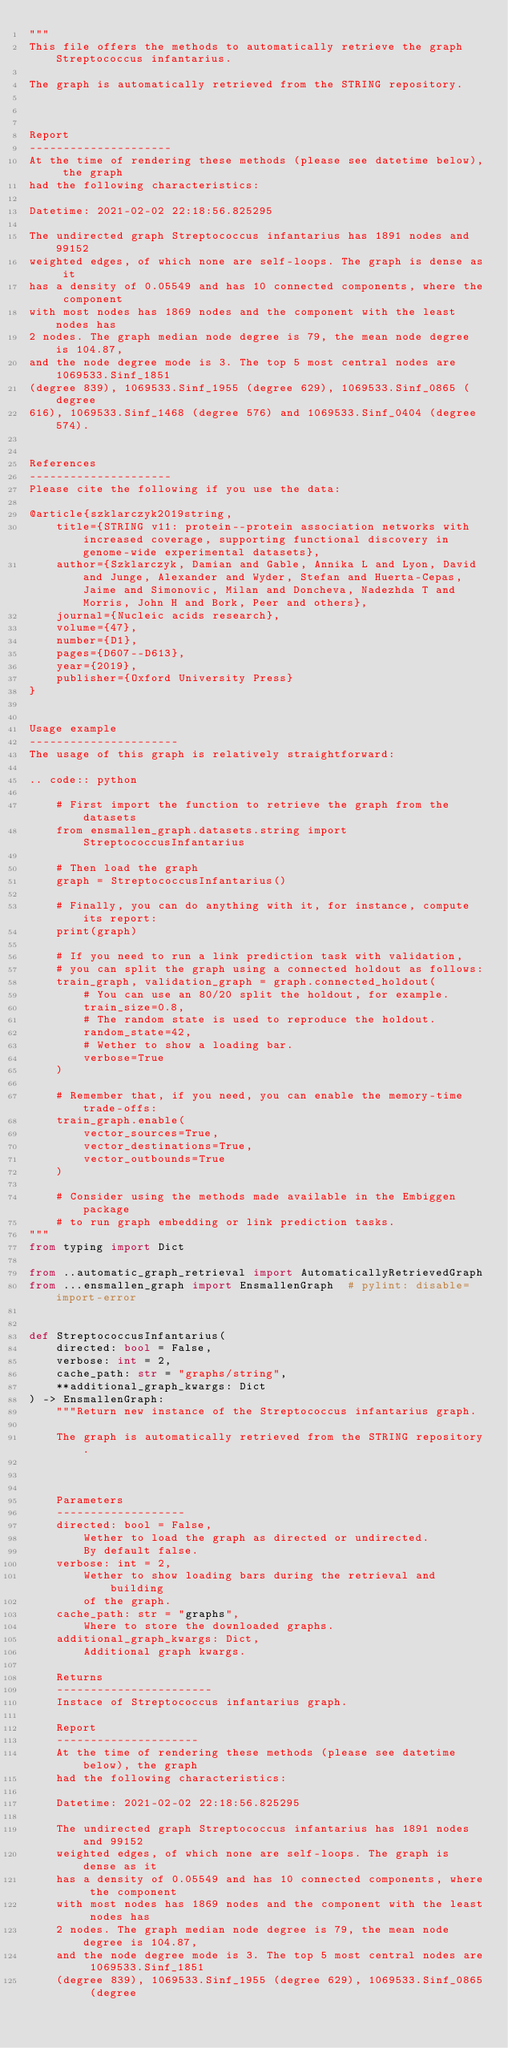Convert code to text. <code><loc_0><loc_0><loc_500><loc_500><_Python_>"""
This file offers the methods to automatically retrieve the graph Streptococcus infantarius.

The graph is automatically retrieved from the STRING repository. 



Report
---------------------
At the time of rendering these methods (please see datetime below), the graph
had the following characteristics:

Datetime: 2021-02-02 22:18:56.825295

The undirected graph Streptococcus infantarius has 1891 nodes and 99152
weighted edges, of which none are self-loops. The graph is dense as it
has a density of 0.05549 and has 10 connected components, where the component
with most nodes has 1869 nodes and the component with the least nodes has
2 nodes. The graph median node degree is 79, the mean node degree is 104.87,
and the node degree mode is 3. The top 5 most central nodes are 1069533.Sinf_1851
(degree 839), 1069533.Sinf_1955 (degree 629), 1069533.Sinf_0865 (degree
616), 1069533.Sinf_1468 (degree 576) and 1069533.Sinf_0404 (degree 574).


References
---------------------
Please cite the following if you use the data:

@article{szklarczyk2019string,
    title={STRING v11: protein--protein association networks with increased coverage, supporting functional discovery in genome-wide experimental datasets},
    author={Szklarczyk, Damian and Gable, Annika L and Lyon, David and Junge, Alexander and Wyder, Stefan and Huerta-Cepas, Jaime and Simonovic, Milan and Doncheva, Nadezhda T and Morris, John H and Bork, Peer and others},
    journal={Nucleic acids research},
    volume={47},
    number={D1},
    pages={D607--D613},
    year={2019},
    publisher={Oxford University Press}
}


Usage example
----------------------
The usage of this graph is relatively straightforward:

.. code:: python

    # First import the function to retrieve the graph from the datasets
    from ensmallen_graph.datasets.string import StreptococcusInfantarius

    # Then load the graph
    graph = StreptococcusInfantarius()

    # Finally, you can do anything with it, for instance, compute its report:
    print(graph)

    # If you need to run a link prediction task with validation,
    # you can split the graph using a connected holdout as follows:
    train_graph, validation_graph = graph.connected_holdout(
        # You can use an 80/20 split the holdout, for example.
        train_size=0.8,
        # The random state is used to reproduce the holdout.
        random_state=42,
        # Wether to show a loading bar.
        verbose=True
    )

    # Remember that, if you need, you can enable the memory-time trade-offs:
    train_graph.enable(
        vector_sources=True,
        vector_destinations=True,
        vector_outbounds=True
    )

    # Consider using the methods made available in the Embiggen package
    # to run graph embedding or link prediction tasks.
"""
from typing import Dict

from ..automatic_graph_retrieval import AutomaticallyRetrievedGraph
from ...ensmallen_graph import EnsmallenGraph  # pylint: disable=import-error


def StreptococcusInfantarius(
    directed: bool = False,
    verbose: int = 2,
    cache_path: str = "graphs/string",
    **additional_graph_kwargs: Dict
) -> EnsmallenGraph:
    """Return new instance of the Streptococcus infantarius graph.

    The graph is automatically retrieved from the STRING repository. 

	

    Parameters
    -------------------
    directed: bool = False,
        Wether to load the graph as directed or undirected.
        By default false.
    verbose: int = 2,
        Wether to show loading bars during the retrieval and building
        of the graph.
    cache_path: str = "graphs",
        Where to store the downloaded graphs.
    additional_graph_kwargs: Dict,
        Additional graph kwargs.

    Returns
    -----------------------
    Instace of Streptococcus infantarius graph.

	Report
	---------------------
	At the time of rendering these methods (please see datetime below), the graph
	had the following characteristics:
	
	Datetime: 2021-02-02 22:18:56.825295
	
	The undirected graph Streptococcus infantarius has 1891 nodes and 99152
	weighted edges, of which none are self-loops. The graph is dense as it
	has a density of 0.05549 and has 10 connected components, where the component
	with most nodes has 1869 nodes and the component with the least nodes has
	2 nodes. The graph median node degree is 79, the mean node degree is 104.87,
	and the node degree mode is 3. The top 5 most central nodes are 1069533.Sinf_1851
	(degree 839), 1069533.Sinf_1955 (degree 629), 1069533.Sinf_0865 (degree</code> 